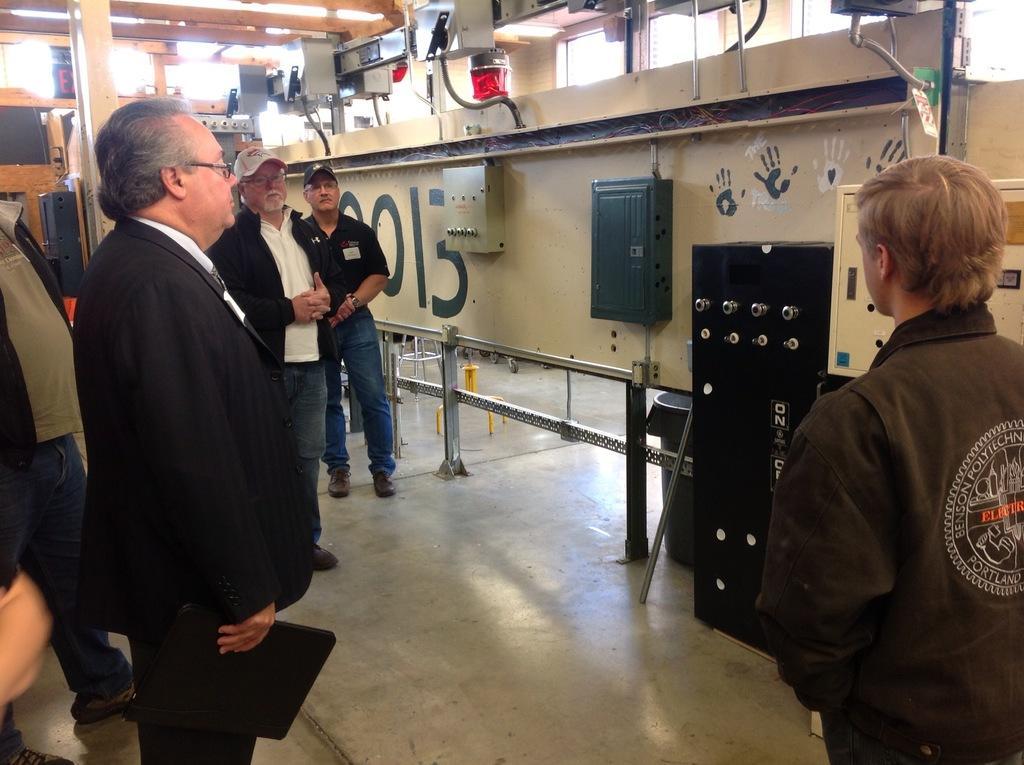How would you summarize this image in a sentence or two? In this picture, there is a huge machinery on the top right. Before the machinery, there are people. Towards the left, there are four men wearing black jackets except the one men wearing black t shirt. A person towards the left, he is holding a file and staring at the machine. Towards the right, there is another person wearing brown jacket. 